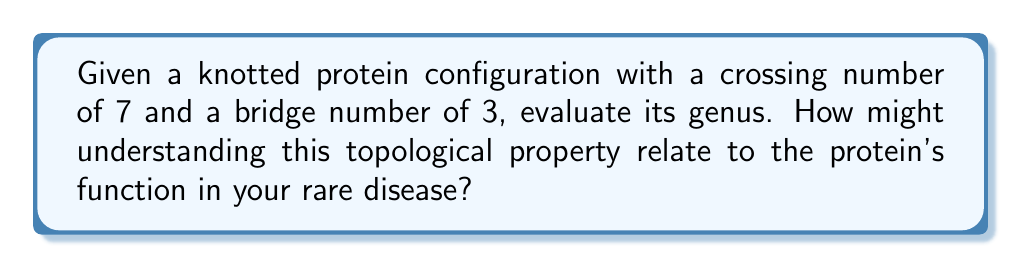Can you solve this math problem? To evaluate the genus of a knotted protein configuration, we'll use the following steps:

1. Recall the relationship between genus (g), crossing number (c), and bridge number (b) for a knot:

   $$2g \leq c - 2b + 2$$

2. We're given:
   - Crossing number (c) = 7
   - Bridge number (b) = 3

3. Substitute these values into the inequality:

   $$2g \leq 7 - 2(3) + 2$$

4. Simplify:

   $$2g \leq 7 - 6 + 2 = 3$$

5. Solve for g:

   $$g \leq \frac{3}{2}$$

6. Since the genus must be a non-negative integer, the maximum possible genus is 1.

Understanding the genus of a knotted protein can provide insights into its complexity and potential interactions. In the context of a rare disease, a higher genus might indicate a more intricate protein structure, which could affect its function or misfolding tendencies, potentially contributing to the disease mechanism.
Answer: 1 